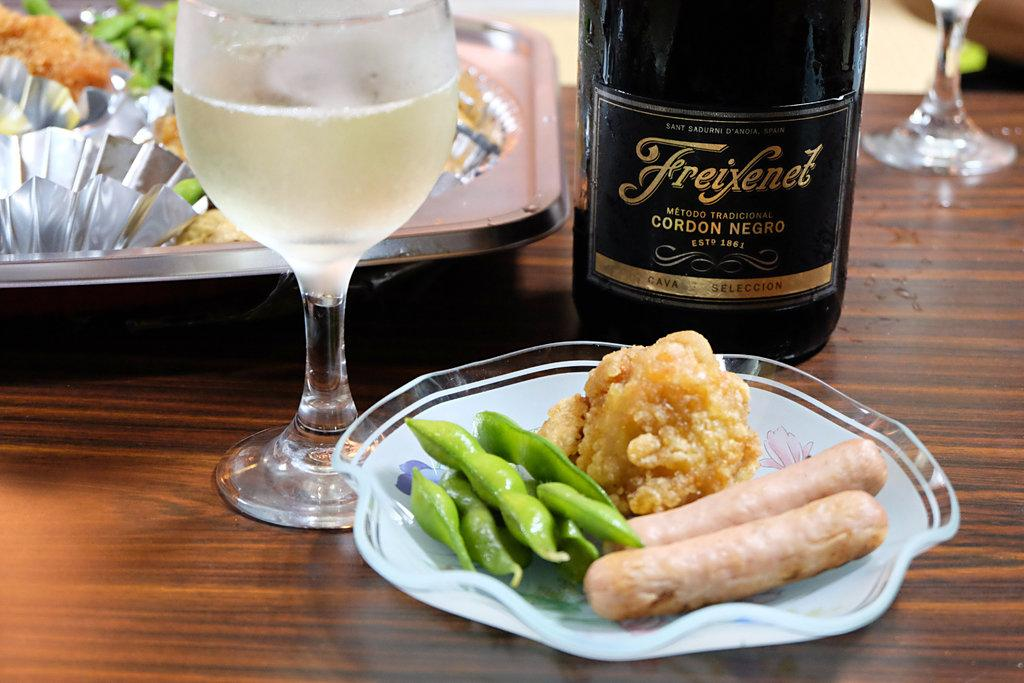What piece of furniture is present in the image? There is a table in the image. What is placed on the table? There is a serving plate with food, a glass tumbler with a beverage, a beverage bottle, and a tray containing food on the table. What type of beverage is in the glass tumbler? The type of beverage in the glass tumbler cannot be determined from the image. How is the food being served or presented on the table? The food is being served on a serving plate and a tray. What type of flowers are arranged in a vase on the table in the image? There are no flowers or vase present in the image. What type of music is playing in the background of the image? There is no indication of music or any sound in the image. 